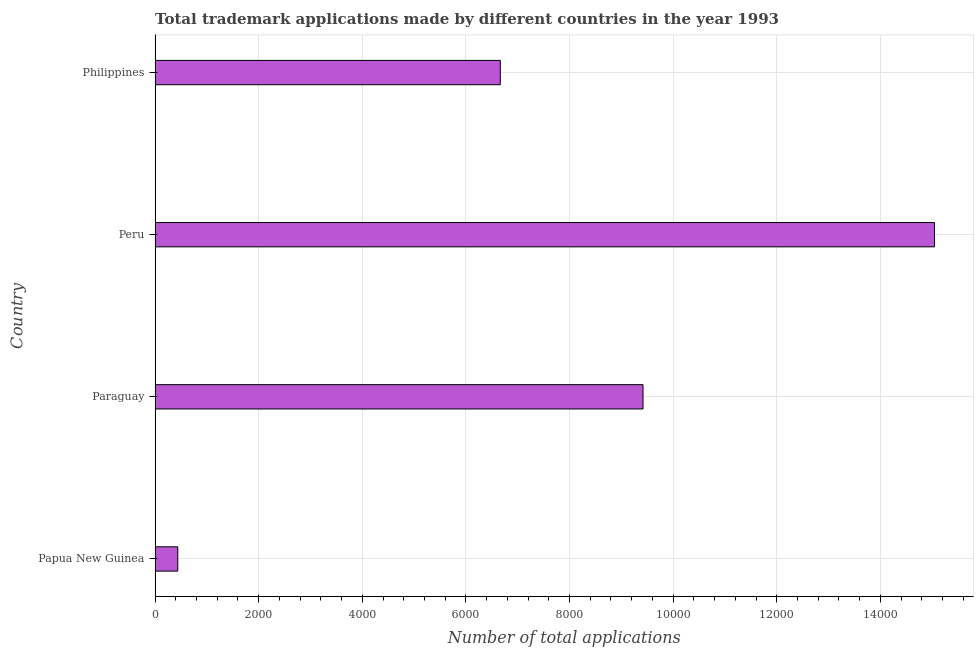Does the graph contain any zero values?
Give a very brief answer. No. What is the title of the graph?
Offer a very short reply. Total trademark applications made by different countries in the year 1993. What is the label or title of the X-axis?
Offer a terse response. Number of total applications. What is the label or title of the Y-axis?
Offer a terse response. Country. What is the number of trademark applications in Papua New Guinea?
Provide a succinct answer. 438. Across all countries, what is the maximum number of trademark applications?
Your answer should be very brief. 1.50e+04. Across all countries, what is the minimum number of trademark applications?
Ensure brevity in your answer.  438. In which country was the number of trademark applications maximum?
Ensure brevity in your answer.  Peru. In which country was the number of trademark applications minimum?
Your response must be concise. Papua New Guinea. What is the sum of the number of trademark applications?
Keep it short and to the point. 3.16e+04. What is the difference between the number of trademark applications in Papua New Guinea and Philippines?
Offer a very short reply. -6226. What is the average number of trademark applications per country?
Provide a succinct answer. 7891. What is the median number of trademark applications?
Offer a terse response. 8041.5. What is the ratio of the number of trademark applications in Peru to that in Philippines?
Give a very brief answer. 2.26. Is the number of trademark applications in Paraguay less than that in Philippines?
Offer a terse response. No. What is the difference between the highest and the second highest number of trademark applications?
Keep it short and to the point. 5627. Is the sum of the number of trademark applications in Papua New Guinea and Peru greater than the maximum number of trademark applications across all countries?
Offer a terse response. Yes. What is the difference between the highest and the lowest number of trademark applications?
Your answer should be very brief. 1.46e+04. In how many countries, is the number of trademark applications greater than the average number of trademark applications taken over all countries?
Give a very brief answer. 2. Are all the bars in the graph horizontal?
Provide a short and direct response. Yes. How many countries are there in the graph?
Provide a succinct answer. 4. What is the difference between two consecutive major ticks on the X-axis?
Offer a very short reply. 2000. Are the values on the major ticks of X-axis written in scientific E-notation?
Your answer should be very brief. No. What is the Number of total applications of Papua New Guinea?
Make the answer very short. 438. What is the Number of total applications of Paraguay?
Provide a succinct answer. 9419. What is the Number of total applications of Peru?
Ensure brevity in your answer.  1.50e+04. What is the Number of total applications in Philippines?
Offer a very short reply. 6664. What is the difference between the Number of total applications in Papua New Guinea and Paraguay?
Give a very brief answer. -8981. What is the difference between the Number of total applications in Papua New Guinea and Peru?
Your response must be concise. -1.46e+04. What is the difference between the Number of total applications in Papua New Guinea and Philippines?
Provide a short and direct response. -6226. What is the difference between the Number of total applications in Paraguay and Peru?
Provide a succinct answer. -5627. What is the difference between the Number of total applications in Paraguay and Philippines?
Your answer should be compact. 2755. What is the difference between the Number of total applications in Peru and Philippines?
Provide a short and direct response. 8382. What is the ratio of the Number of total applications in Papua New Guinea to that in Paraguay?
Provide a short and direct response. 0.05. What is the ratio of the Number of total applications in Papua New Guinea to that in Peru?
Offer a terse response. 0.03. What is the ratio of the Number of total applications in Papua New Guinea to that in Philippines?
Your answer should be compact. 0.07. What is the ratio of the Number of total applications in Paraguay to that in Peru?
Keep it short and to the point. 0.63. What is the ratio of the Number of total applications in Paraguay to that in Philippines?
Ensure brevity in your answer.  1.41. What is the ratio of the Number of total applications in Peru to that in Philippines?
Your answer should be compact. 2.26. 